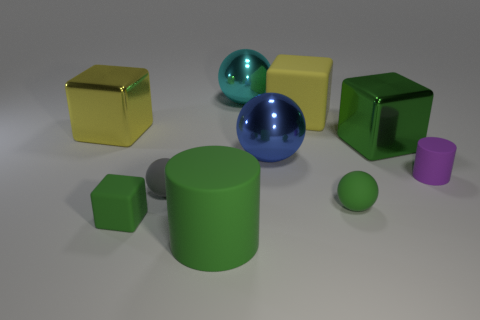Subtract all cylinders. How many objects are left? 8 Add 4 blue objects. How many blue objects are left? 5 Add 2 big rubber cubes. How many big rubber cubes exist? 3 Subtract 0 purple spheres. How many objects are left? 10 Subtract all big blue objects. Subtract all purple matte cylinders. How many objects are left? 8 